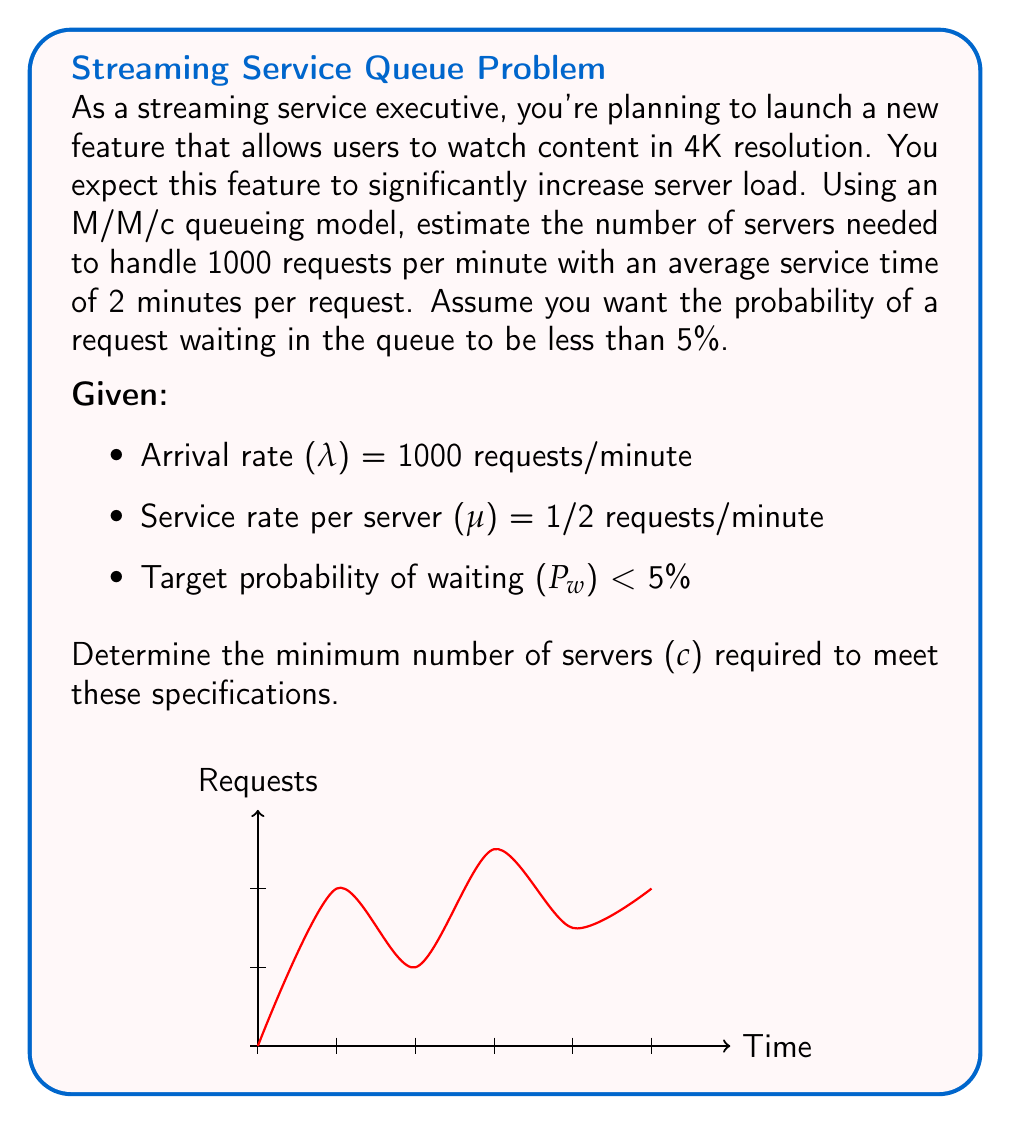Provide a solution to this math problem. Let's approach this step-by-step using the M/M/c queueing model:

1) First, calculate the traffic intensity (ρ):
   $$\rho = \frac{\lambda}{c\mu}$$

2) For stability, we need ρ < 1, so:
   $$\frac{1000}{c(1/2)} < 1$$
   $$2000 < c$$
   
   This gives us a lower bound of 2000 servers.

3) The probability of waiting (P_w) in an M/M/c queue is given by the Erlang C formula:
   $$P_w = \frac{(c\rho)^c}{c!(1-\rho)} \cdot P_0$$

   Where P_0 is the probability of an empty system:
   $$P_0 = \left[\sum_{n=0}^{c-1}\frac{(c\rho)^n}{n!} + \frac{(c\rho)^c}{c!(1-\rho)}\right]^{-1}$$

4) We need to find the smallest c for which P_w < 0.05

5) Using an iterative approach or a calculator designed for queueing theory, we can find that the minimum number of servers needed is 2082.

6) Verification:
   For c = 2082:
   $$\rho = \frac{1000}{2082(1/2)} \approx 0.9606$$
   
   Calculating P_0 and P_w (which involves complex calculations), we get:
   $$P_w \approx 0.0499 < 0.05$$

   For c = 2081:
   $$P_w \approx 0.0502 > 0.05$$

Therefore, 2082 is the minimum number of servers required.
Answer: 2082 servers 